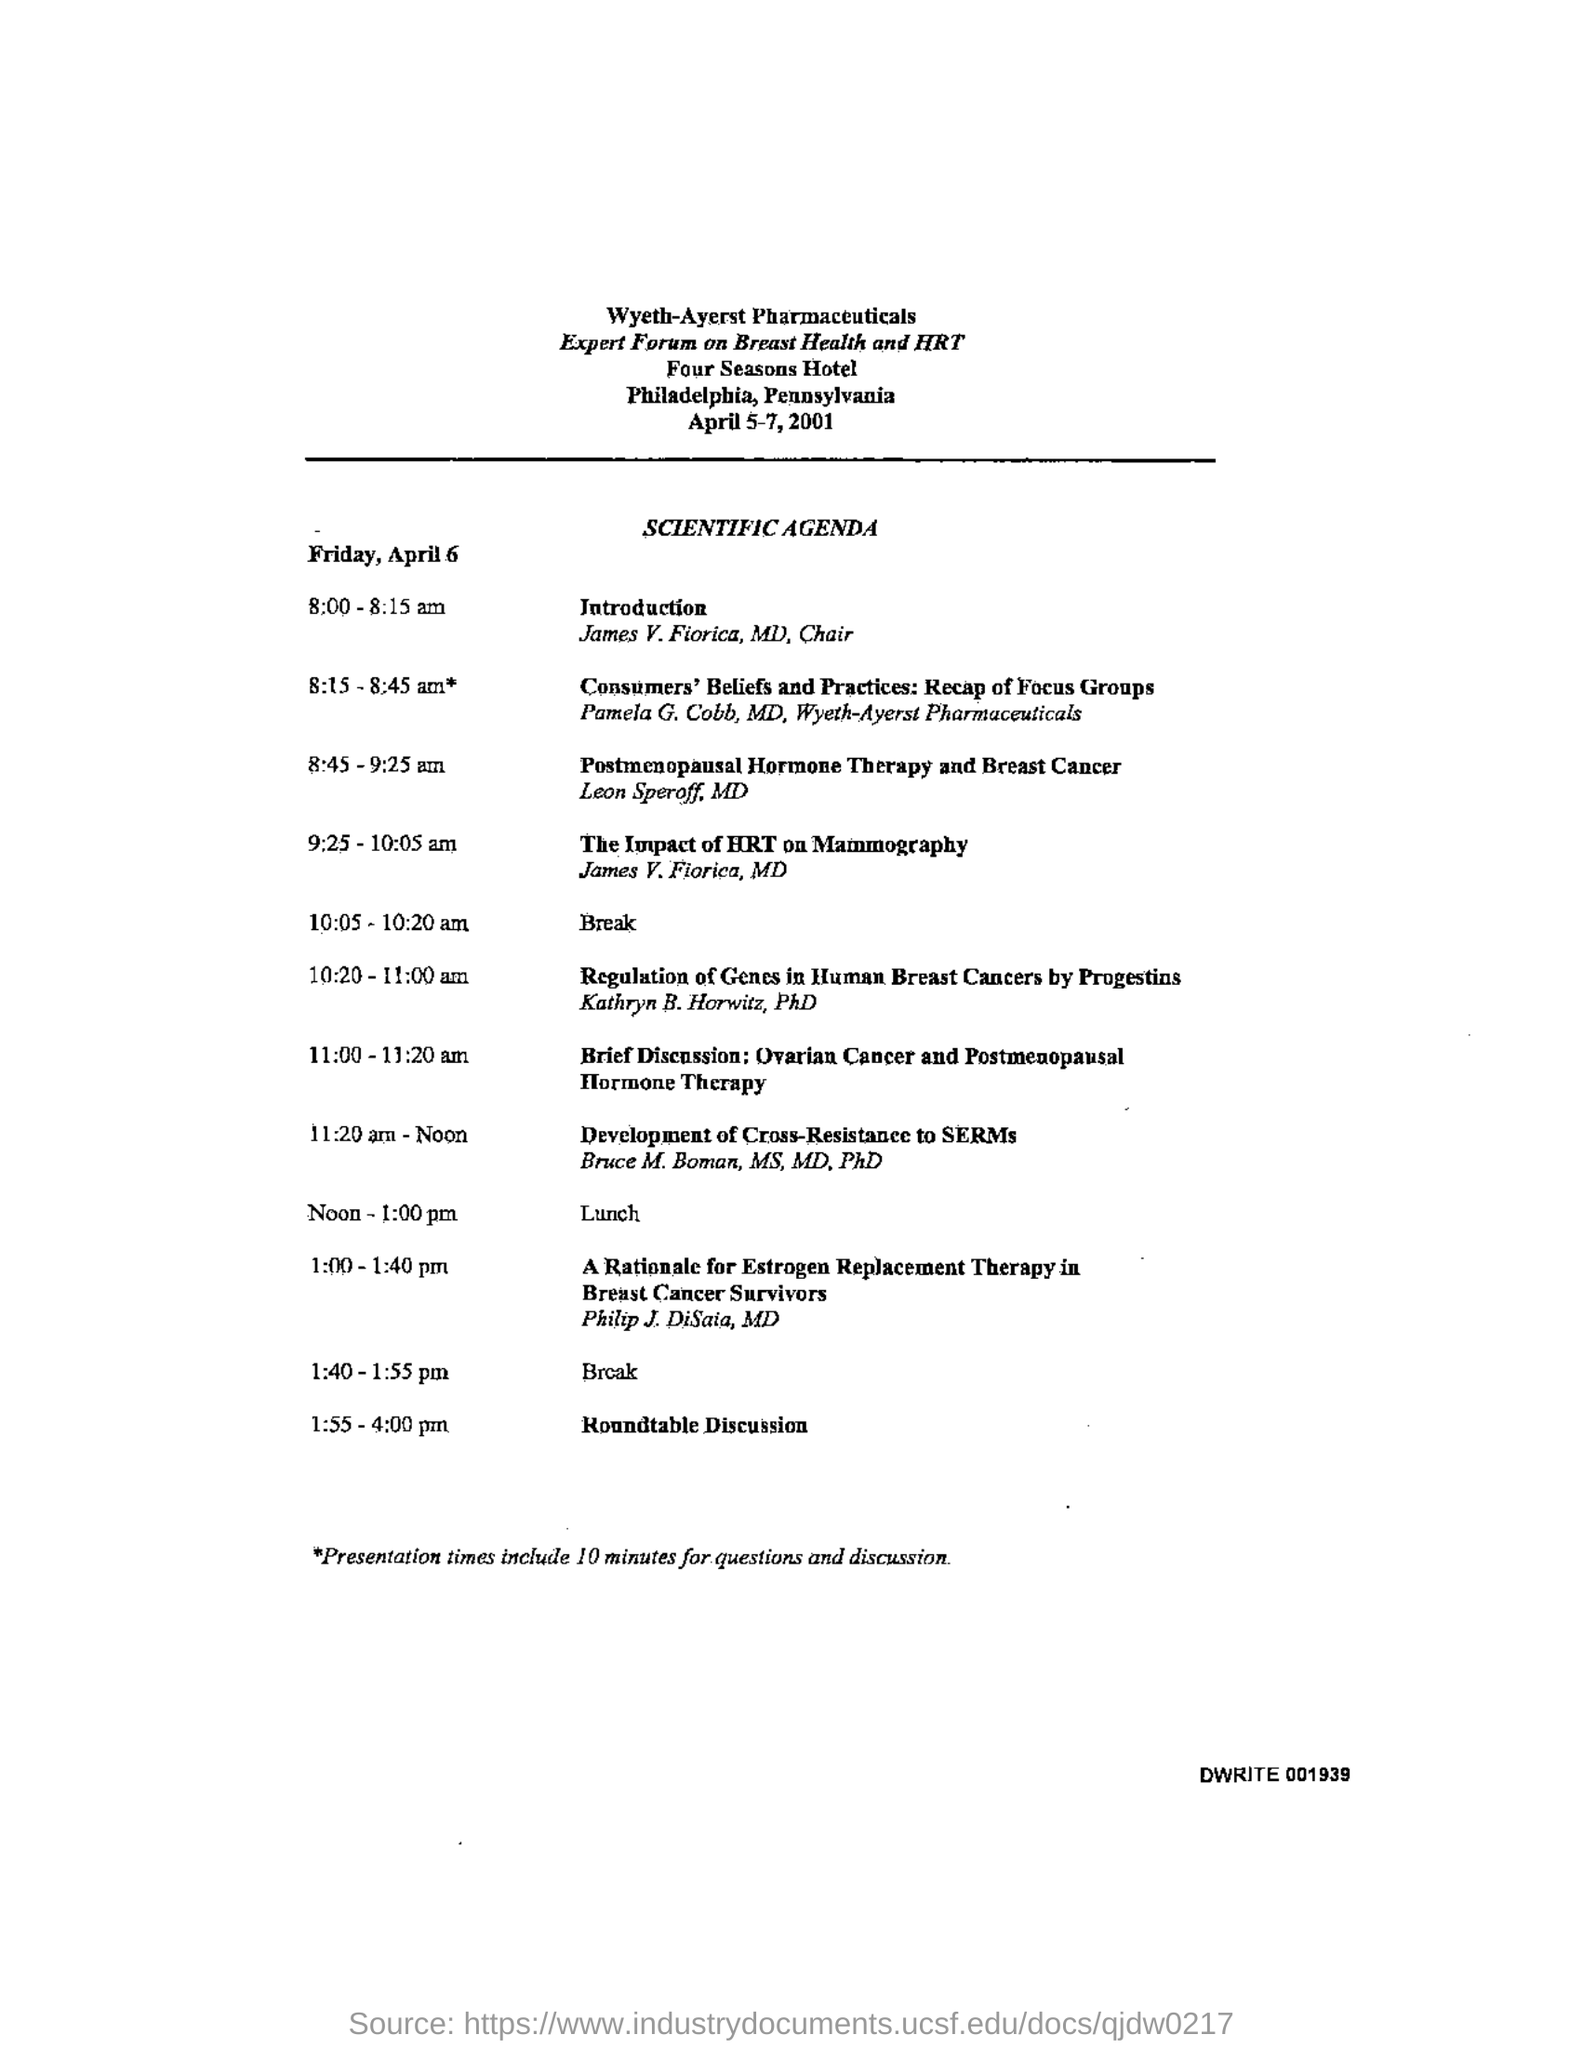Highlight a few significant elements in this photo. The Introduction is scheduled to take place between the hours of 8:00 and 8:15 am. The forum is held at the Four Seasons Hotel. Four Seasons Hotel is located in Philadelphia. The forum is scheduled to take place from April 5-7, 2001. The lunch will take place from noon to 1:00 pm. 